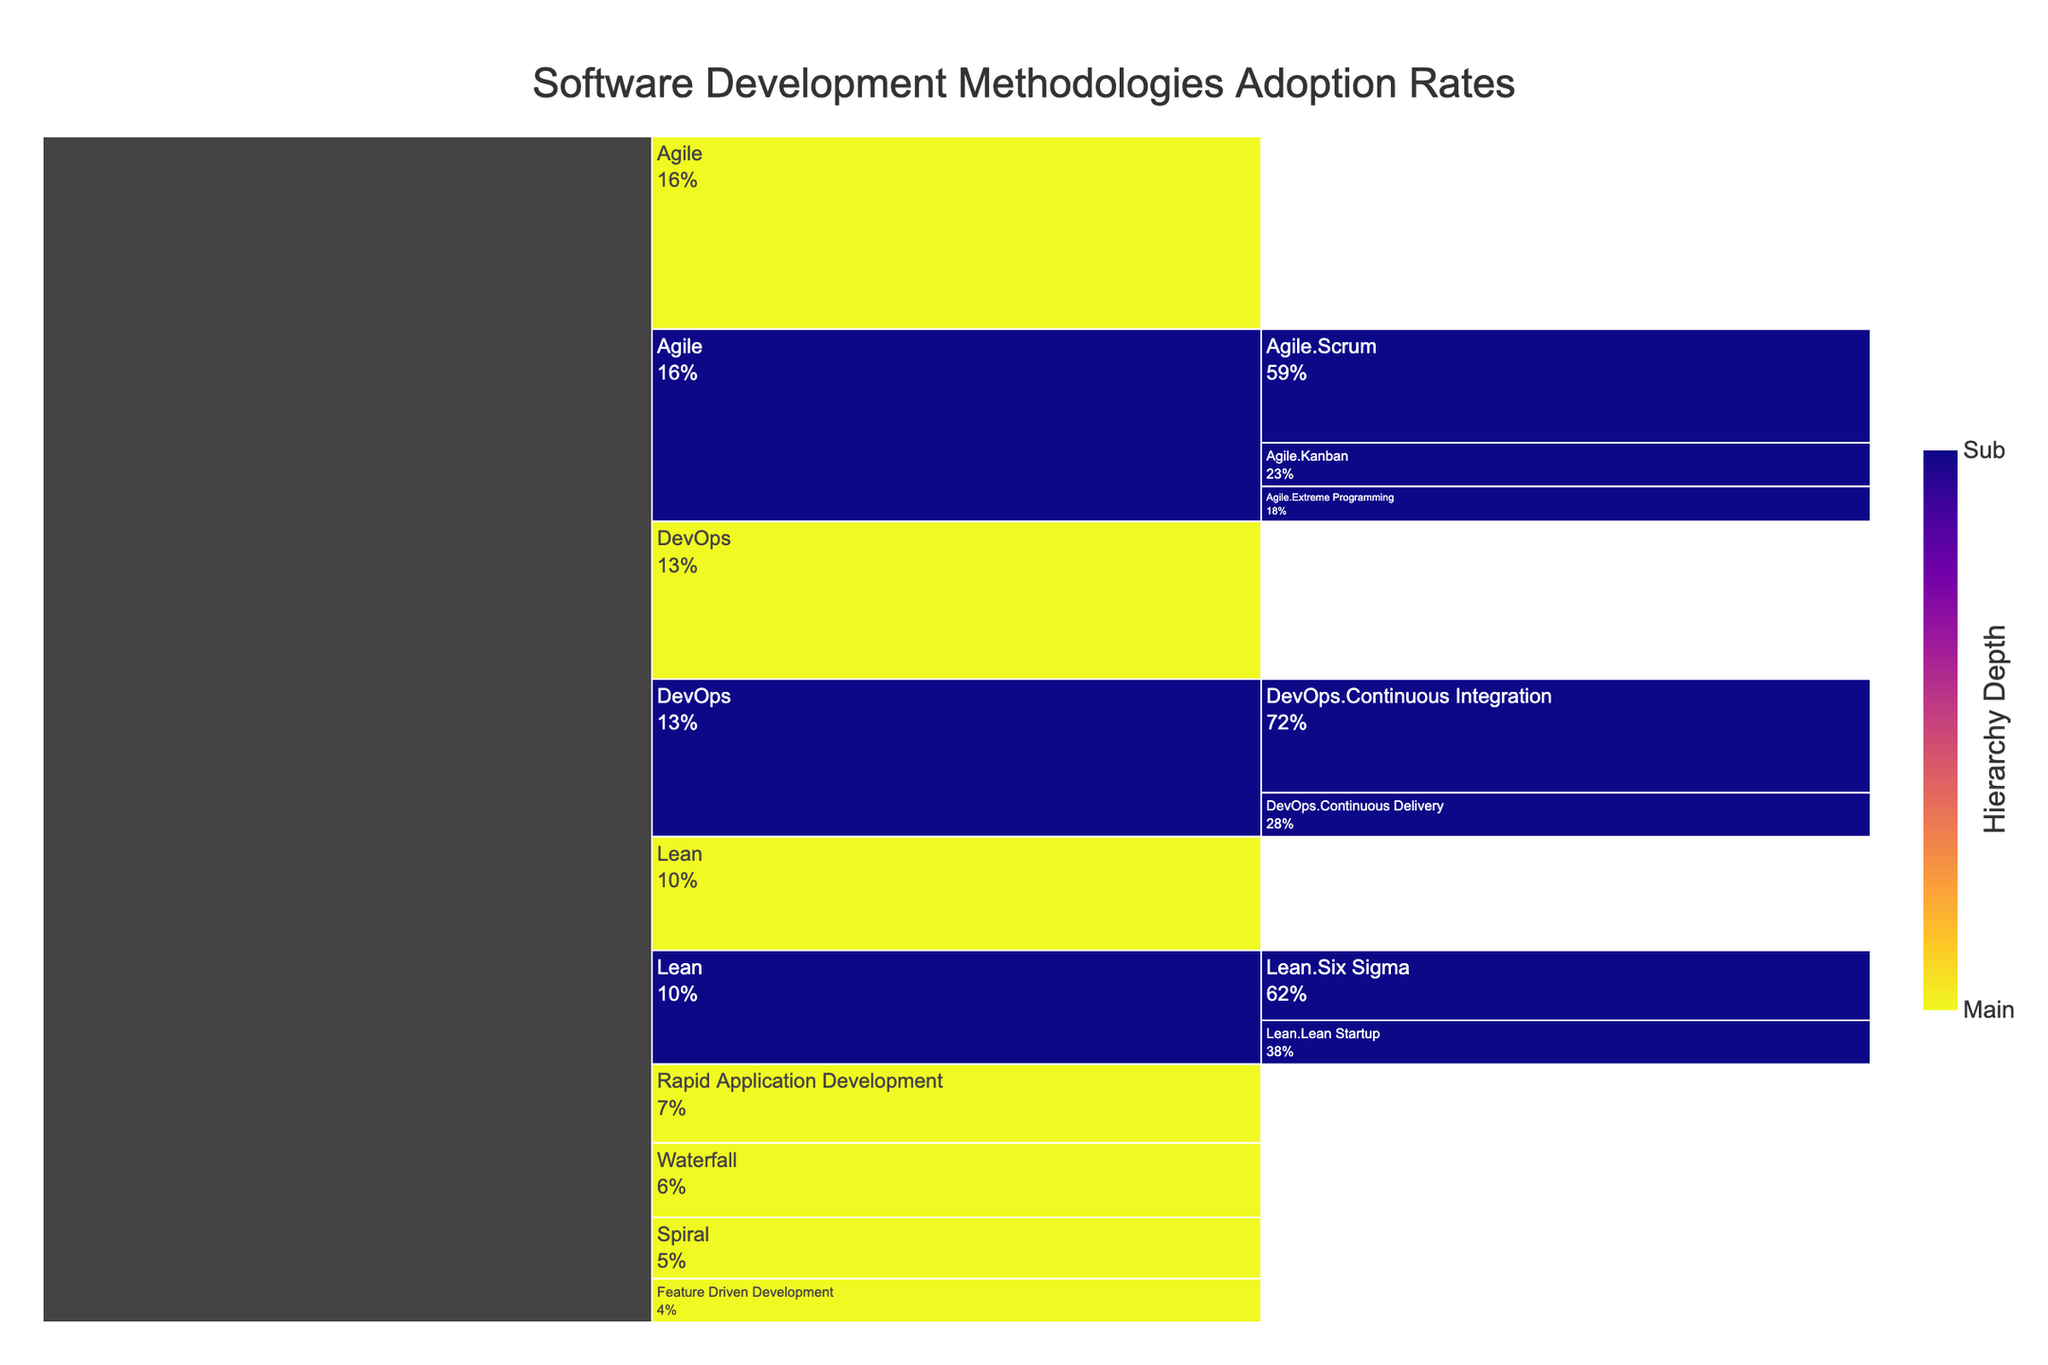What is the title of the icicle chart? The title of the icicle chart is located at the top and is clearly written.
Answer: Software Development Methodologies Adoption Rates Which methodology has the highest adoption rate among large enterprises? Look at the segment corresponding to large enterprises and find the highest value.
Answer: Agile (70%) How do the adoption rates of Agile and DevOps compare across startups? Look at the segments for Agile and DevOps under the startup category and compare their values.
Answer: Agile is 40% and DevOps is 30% What is the total adoption rate of Lean methodologies in medium businesses? Add the adoption rates of Lean, Lean Startup, and Six Sigma in the Medium Business category.
Answer: 30% (Lean) + 10% (Lean Startup) + 20% (Six Sigma) = 60% Which sub-methodology under DevOps has a higher adoption rate for small businesses, Continuous Integration or Continuous Delivery? Compare the segments for Continuous Integration and Continuous Delivery under DevOps in the small business category.
Answer: Continuous Integration (30%) What is the difference in adoption rate of Waterfall methodology between large enterprises and startups? Subtract the adoption rate of Waterfall in startups from that in large enterprises.
Answer: 30% (Large Enterprise) - 10% (Startup) = 20% Which company size has the highest adoption rate for Rapid Application Development? Look at the corresponding segments for Rapid Application Development across different company sizes and find the highest one.
Answer: Startup (30%) What is the sum of all adoption rates for the Feature Driven Development methodology across all company sizes? Add the adoption rates for Feature Driven Development in large enterprises, medium businesses, small businesses, and startups.
Answer: 5% (Large Enterprise) + 10% (Medium Business) + 15% (Small Business) + 20% (Startup) = 50% Under which main methodology do we see the highest diversification in sub-methodologies for large enterprises? Look at which main methodology has the most sub-methodologies represented for large enterprises.
Answer: Agile (Scrum, Kanban, Extreme Programming) How does the adoption rate of Extreme Programming compare across all company sizes? Examine the segment for Extreme Programming under Agile in each company size and compare the values.
Answer: It is the same across all company sizes (10%) 